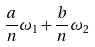<formula> <loc_0><loc_0><loc_500><loc_500>\frac { a } { n } \omega _ { 1 } + \frac { b } { n } \omega _ { 2 }</formula> 